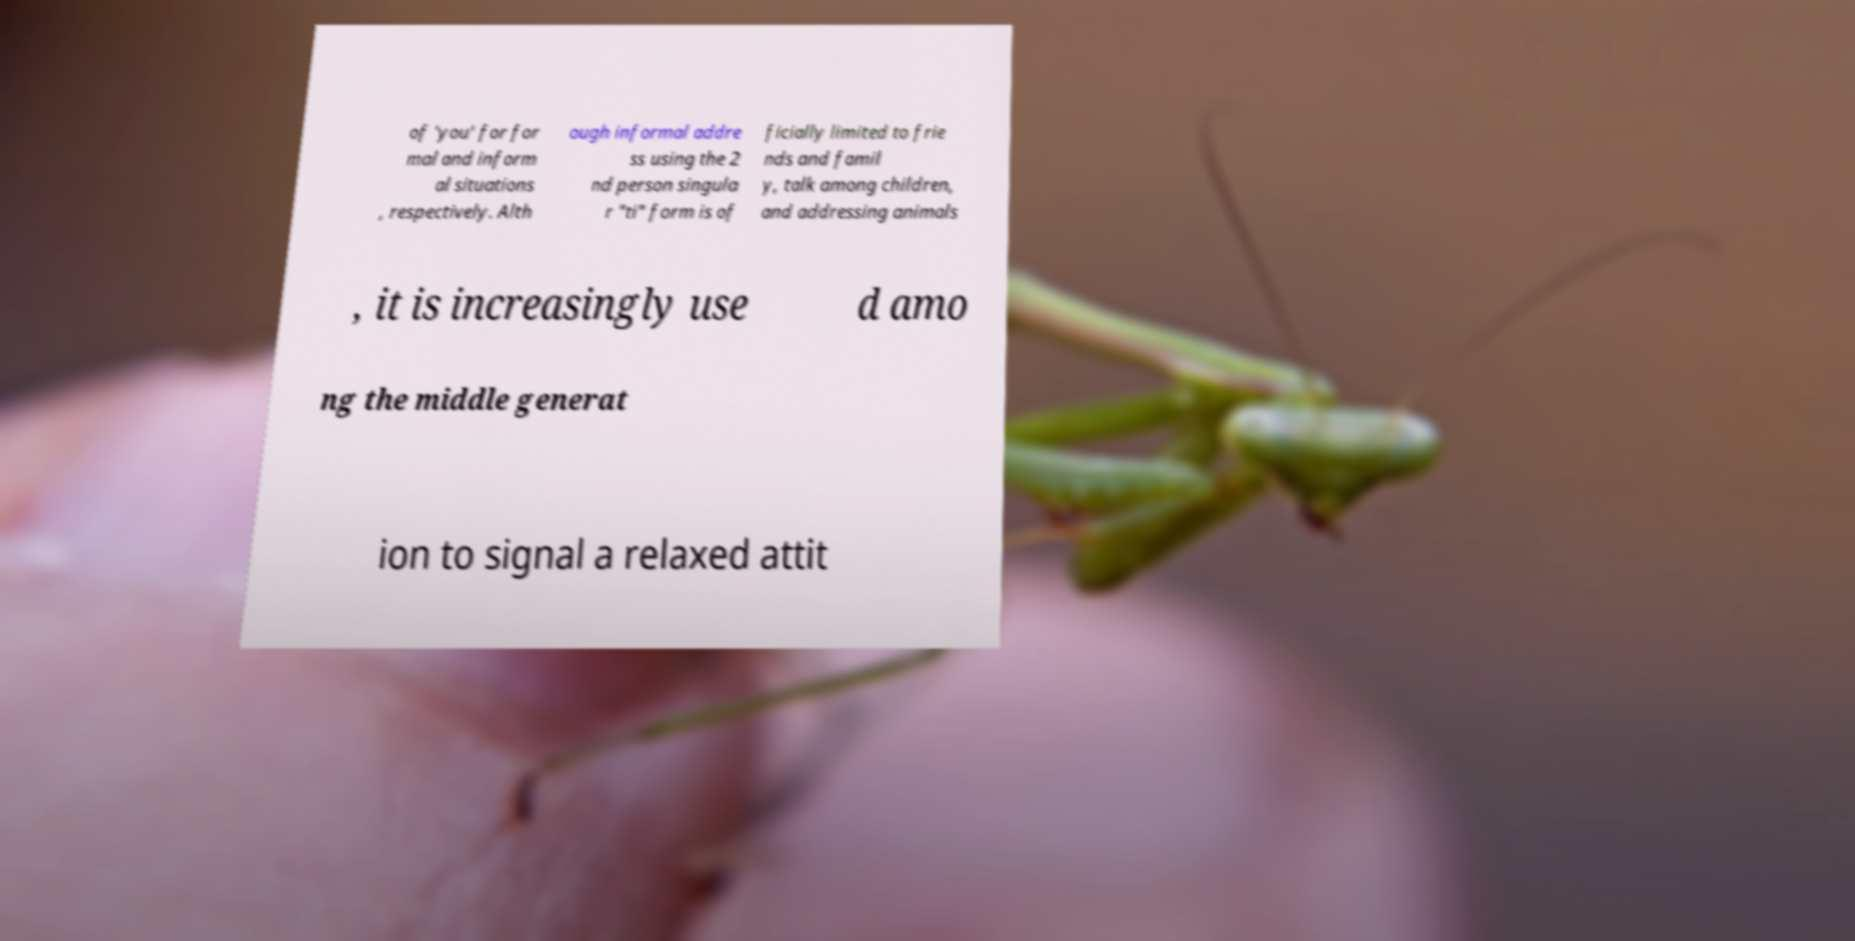Can you accurately transcribe the text from the provided image for me? of 'you' for for mal and inform al situations , respectively. Alth ough informal addre ss using the 2 nd person singula r "ti" form is of ficially limited to frie nds and famil y, talk among children, and addressing animals , it is increasingly use d amo ng the middle generat ion to signal a relaxed attit 